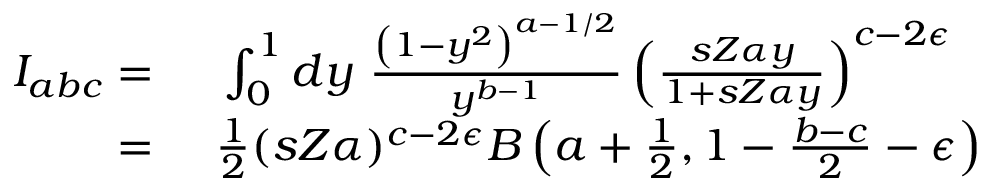Convert formula to latex. <formula><loc_0><loc_0><loc_500><loc_500>\begin{array} { r l } { I _ { a b c } = \ } & \int _ { 0 } ^ { 1 } d y \ \frac { \left ( 1 - y ^ { 2 } \right ) ^ { a - 1 / 2 } } { y ^ { b - 1 } } \left ( \frac { s Z \alpha y } { 1 + s Z \alpha y } \right ) ^ { c - 2 \epsilon } } \\ { = \ } & \frac { 1 } { 2 } ( s Z \alpha ) ^ { c - 2 \epsilon } B \left ( a + \frac { 1 } { 2 } , 1 - \frac { b - c } { 2 } - \epsilon \right ) } \end{array}</formula> 